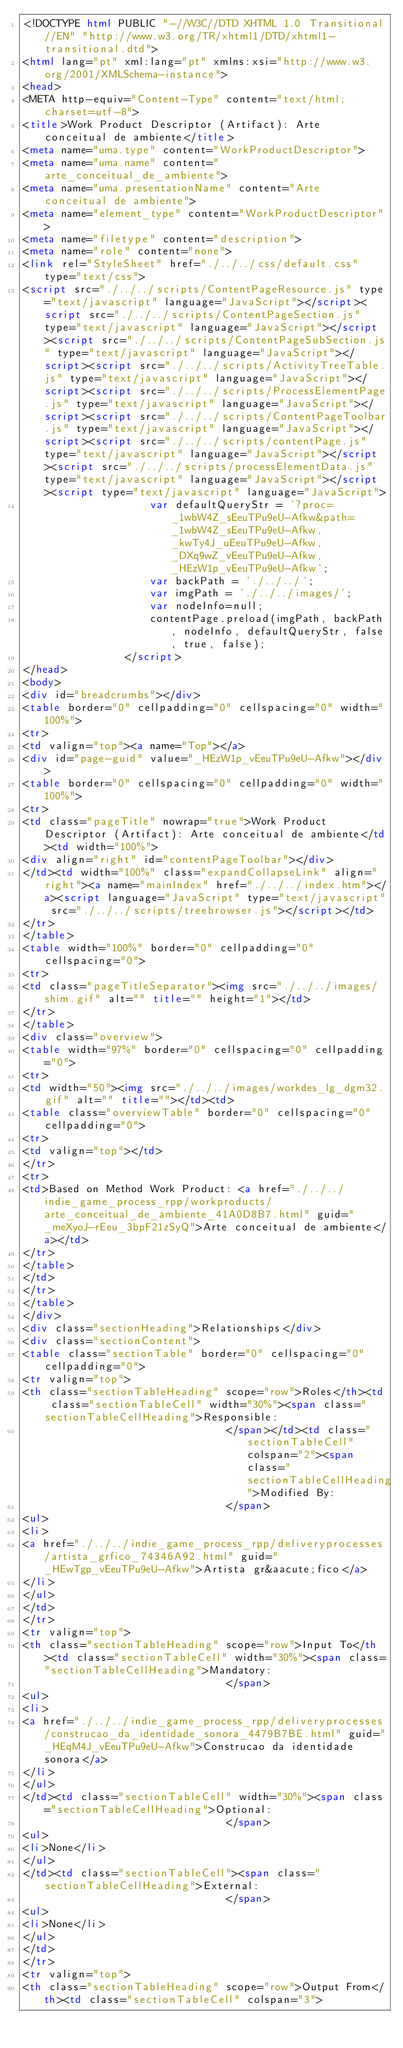Convert code to text. <code><loc_0><loc_0><loc_500><loc_500><_HTML_><!DOCTYPE html PUBLIC "-//W3C//DTD XHTML 1.0 Transitional//EN" "http://www.w3.org/TR/xhtml1/DTD/xhtml1-transitional.dtd">
<html lang="pt" xml:lang="pt" xmlns:xsi="http://www.w3.org/2001/XMLSchema-instance">
<head>
<META http-equiv="Content-Type" content="text/html; charset=utf-8">
<title>Work Product Descriptor (Artifact): Arte conceitual de ambiente</title>
<meta name="uma.type" content="WorkProductDescriptor">
<meta name="uma.name" content="arte_conceitual_de_ambiente">
<meta name="uma.presentationName" content="Arte conceitual de ambiente">
<meta name="element_type" content="WorkProductDescriptor">
<meta name="filetype" content="description">
<meta name="role" content="none">
<link rel="StyleSheet" href="./../../css/default.css" type="text/css">
<script src="./../../scripts/ContentPageResource.js" type="text/javascript" language="JavaScript"></script><script src="./../../scripts/ContentPageSection.js" type="text/javascript" language="JavaScript"></script><script src="./../../scripts/ContentPageSubSection.js" type="text/javascript" language="JavaScript"></script><script src="./../../scripts/ActivityTreeTable.js" type="text/javascript" language="JavaScript"></script><script src="./../../scripts/ProcessElementPage.js" type="text/javascript" language="JavaScript"></script><script src="./../../scripts/ContentPageToolbar.js" type="text/javascript" language="JavaScript"></script><script src="./../../scripts/contentPage.js" type="text/javascript" language="JavaScript"></script><script src="./../../scripts/processElementData.js" type="text/javascript" language="JavaScript"></script><script type="text/javascript" language="JavaScript">
					var defaultQueryStr = '?proc=_1wbW4Z_sEeuTPu9eU-Afkw&path=_1wbW4Z_sEeuTPu9eU-Afkw,_kwTy4J_uEeuTPu9eU-Afkw,_DXq9wZ_vEeuTPu9eU-Afkw,_HEzW1p_vEeuTPu9eU-Afkw';
					var backPath = './../../';
					var imgPath = './../../images/';
					var nodeInfo=null;
					contentPage.preload(imgPath, backPath, nodeInfo, defaultQueryStr, false, true, false);
				</script>
</head>
<body>
<div id="breadcrumbs"></div>
<table border="0" cellpadding="0" cellspacing="0" width="100%">
<tr>
<td valign="top"><a name="Top"></a>
<div id="page-guid" value="_HEzW1p_vEeuTPu9eU-Afkw"></div>
<table border="0" cellspacing="0" cellpadding="0" width="100%">
<tr>
<td class="pageTitle" nowrap="true">Work Product Descriptor (Artifact): Arte conceitual de ambiente</td><td width="100%">
<div align="right" id="contentPageToolbar"></div>
</td><td width="100%" class="expandCollapseLink" align="right"><a name="mainIndex" href="./../../index.htm"></a><script language="JavaScript" type="text/javascript" src="./../../scripts/treebrowser.js"></script></td>
</tr>
</table>
<table width="100%" border="0" cellpadding="0" cellspacing="0">
<tr>
<td class="pageTitleSeparator"><img src="./../../images/shim.gif" alt="" title="" height="1"></td>
</tr>
</table>
<div class="overview">
<table width="97%" border="0" cellspacing="0" cellpadding="0">
<tr>
<td width="50"><img src="./../../images/workdes_lg_dgm32.gif" alt="" title=""></td><td>
<table class="overviewTable" border="0" cellspacing="0" cellpadding="0">
<tr>
<td valign="top"></td>
</tr>
<tr>
<td>Based on Method Work Product: <a href="./../../indie_game_process_rpp/workproducts/arte_conceitual_de_ambiente_41A0D8B7.html" guid="_meXyoJ-rEeu_3bpF21zSyQ">Arte conceitual de ambiente</a></td>
</tr>
</table>
</td>
</tr>
</table>
</div>
<div class="sectionHeading">Relationships</div>
<div class="sectionContent">
<table class="sectionTable" border="0" cellspacing="0" cellpadding="0">
<tr valign="top">
<th class="sectionTableHeading" scope="row">Roles</th><td class="sectionTableCell" width="30%"><span class="sectionTableCellHeading">Responsible:
								</span></td><td class="sectionTableCell" colspan="2"><span class="sectionTableCellHeading">Modified By:
								</span>
<ul>
<li>
<a href="./../../indie_game_process_rpp/deliveryprocesses/artista_grfico_74346A92.html" guid="_HEwTgp_vEeuTPu9eU-Afkw">Artista gr&aacute;fico</a>
</li>
</ul>
</td>
</tr>
<tr valign="top">
<th class="sectionTableHeading" scope="row">Input To</th><td class="sectionTableCell" width="30%"><span class="sectionTableCellHeading">Mandatory:
								</span>
<ul>
<li>
<a href="./../../indie_game_process_rpp/deliveryprocesses/construcao_da_identidade_sonora_4479B7BE.html" guid="_HEqM4J_vEeuTPu9eU-Afkw">Construcao da identidade sonora</a>
</li>
</ul>
</td><td class="sectionTableCell" width="30%"><span class="sectionTableCellHeading">Optional:
								</span>
<ul>
<li>None</li>
</ul>
</td><td class="sectionTableCell"><span class="sectionTableCellHeading">External:
								</span>
<ul>
<li>None</li>
</ul>
</td>
</tr>
<tr valign="top">
<th class="sectionTableHeading" scope="row">Output From</th><td class="sectionTableCell" colspan="3"></code> 